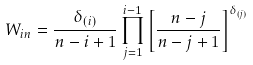<formula> <loc_0><loc_0><loc_500><loc_500>W _ { i n } = \frac { \delta _ { ( i ) } } { n - i + 1 } \prod _ { j = 1 } ^ { i - 1 } \left [ \frac { n - j } { n - j + 1 } \right ] ^ { \delta _ { ( j ) } }</formula> 